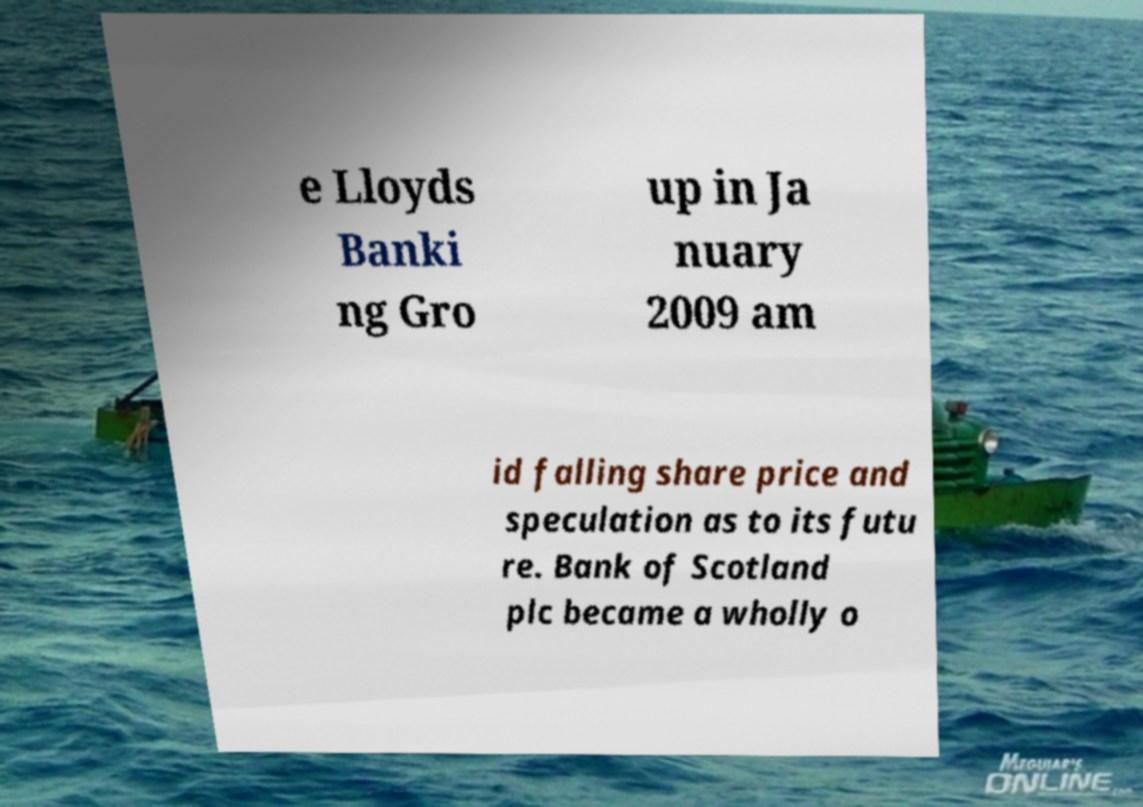What messages or text are displayed in this image? I need them in a readable, typed format. e Lloyds Banki ng Gro up in Ja nuary 2009 am id falling share price and speculation as to its futu re. Bank of Scotland plc became a wholly o 